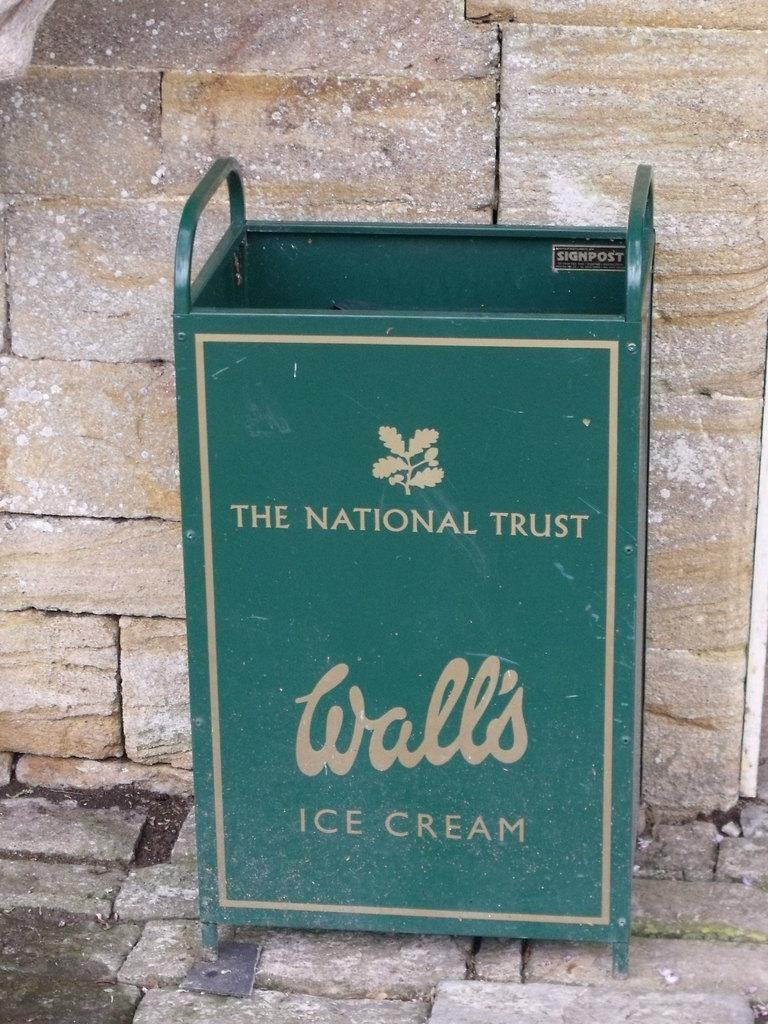<image>
Offer a succinct explanation of the picture presented. The green container has 'The National Trust' and 'Wall's Ice Cream' printed on it. 